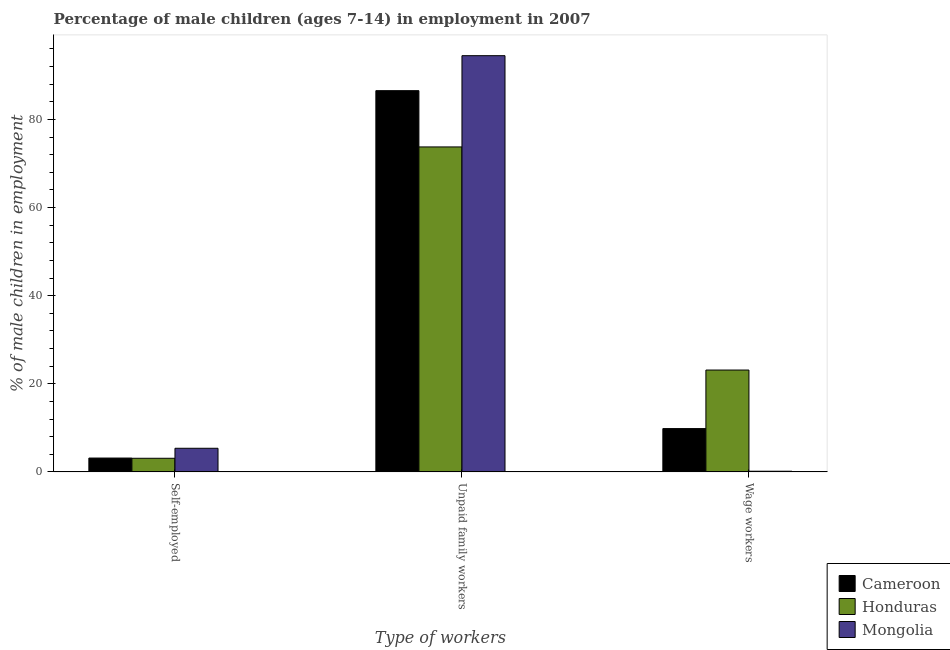How many different coloured bars are there?
Give a very brief answer. 3. How many groups of bars are there?
Keep it short and to the point. 3. Are the number of bars per tick equal to the number of legend labels?
Your response must be concise. Yes. How many bars are there on the 3rd tick from the left?
Keep it short and to the point. 3. How many bars are there on the 3rd tick from the right?
Offer a terse response. 3. What is the label of the 1st group of bars from the left?
Keep it short and to the point. Self-employed. What is the percentage of children employed as unpaid family workers in Mongolia?
Make the answer very short. 94.48. Across all countries, what is the maximum percentage of children employed as unpaid family workers?
Make the answer very short. 94.48. Across all countries, what is the minimum percentage of children employed as unpaid family workers?
Your answer should be very brief. 73.77. In which country was the percentage of self employed children maximum?
Offer a very short reply. Mongolia. In which country was the percentage of self employed children minimum?
Your answer should be compact. Honduras. What is the total percentage of children employed as wage workers in the graph?
Make the answer very short. 33.13. What is the difference between the percentage of self employed children in Honduras and that in Mongolia?
Offer a very short reply. -2.27. What is the difference between the percentage of children employed as unpaid family workers in Honduras and the percentage of self employed children in Mongolia?
Give a very brief answer. 68.4. What is the average percentage of children employed as unpaid family workers per country?
Make the answer very short. 84.93. What is the difference between the percentage of children employed as unpaid family workers and percentage of self employed children in Cameroon?
Provide a short and direct response. 83.39. What is the ratio of the percentage of children employed as unpaid family workers in Cameroon to that in Mongolia?
Give a very brief answer. 0.92. Is the percentage of children employed as wage workers in Mongolia less than that in Honduras?
Offer a terse response. Yes. Is the difference between the percentage of children employed as wage workers in Mongolia and Cameroon greater than the difference between the percentage of children employed as unpaid family workers in Mongolia and Cameroon?
Make the answer very short. No. What is the difference between the highest and the second highest percentage of self employed children?
Your answer should be compact. 2.22. What is the difference between the highest and the lowest percentage of children employed as unpaid family workers?
Provide a succinct answer. 20.71. What does the 1st bar from the left in Wage workers represents?
Provide a succinct answer. Cameroon. What does the 2nd bar from the right in Self-employed represents?
Give a very brief answer. Honduras. How many bars are there?
Your response must be concise. 9. What is the difference between two consecutive major ticks on the Y-axis?
Make the answer very short. 20. Are the values on the major ticks of Y-axis written in scientific E-notation?
Your answer should be very brief. No. Does the graph contain any zero values?
Your answer should be compact. No. Where does the legend appear in the graph?
Your answer should be compact. Bottom right. How many legend labels are there?
Make the answer very short. 3. How are the legend labels stacked?
Provide a short and direct response. Vertical. What is the title of the graph?
Keep it short and to the point. Percentage of male children (ages 7-14) in employment in 2007. What is the label or title of the X-axis?
Provide a succinct answer. Type of workers. What is the label or title of the Y-axis?
Your answer should be compact. % of male children in employment. What is the % of male children in employment in Cameroon in Self-employed?
Ensure brevity in your answer.  3.15. What is the % of male children in employment of Mongolia in Self-employed?
Your answer should be very brief. 5.37. What is the % of male children in employment in Cameroon in Unpaid family workers?
Provide a succinct answer. 86.54. What is the % of male children in employment in Honduras in Unpaid family workers?
Your answer should be compact. 73.77. What is the % of male children in employment of Mongolia in Unpaid family workers?
Provide a succinct answer. 94.48. What is the % of male children in employment in Cameroon in Wage workers?
Provide a succinct answer. 9.84. What is the % of male children in employment of Honduras in Wage workers?
Provide a short and direct response. 23.13. What is the % of male children in employment in Mongolia in Wage workers?
Ensure brevity in your answer.  0.16. Across all Type of workers, what is the maximum % of male children in employment in Cameroon?
Provide a short and direct response. 86.54. Across all Type of workers, what is the maximum % of male children in employment in Honduras?
Provide a succinct answer. 73.77. Across all Type of workers, what is the maximum % of male children in employment in Mongolia?
Offer a terse response. 94.48. Across all Type of workers, what is the minimum % of male children in employment of Cameroon?
Offer a terse response. 3.15. Across all Type of workers, what is the minimum % of male children in employment of Mongolia?
Your answer should be compact. 0.16. What is the total % of male children in employment of Cameroon in the graph?
Your answer should be very brief. 99.53. What is the total % of male children in employment of Honduras in the graph?
Keep it short and to the point. 100. What is the total % of male children in employment of Mongolia in the graph?
Offer a terse response. 100.01. What is the difference between the % of male children in employment of Cameroon in Self-employed and that in Unpaid family workers?
Ensure brevity in your answer.  -83.39. What is the difference between the % of male children in employment of Honduras in Self-employed and that in Unpaid family workers?
Keep it short and to the point. -70.67. What is the difference between the % of male children in employment in Mongolia in Self-employed and that in Unpaid family workers?
Offer a terse response. -89.11. What is the difference between the % of male children in employment in Cameroon in Self-employed and that in Wage workers?
Give a very brief answer. -6.69. What is the difference between the % of male children in employment in Honduras in Self-employed and that in Wage workers?
Provide a succinct answer. -20.03. What is the difference between the % of male children in employment of Mongolia in Self-employed and that in Wage workers?
Keep it short and to the point. 5.21. What is the difference between the % of male children in employment in Cameroon in Unpaid family workers and that in Wage workers?
Provide a succinct answer. 76.7. What is the difference between the % of male children in employment of Honduras in Unpaid family workers and that in Wage workers?
Provide a short and direct response. 50.64. What is the difference between the % of male children in employment of Mongolia in Unpaid family workers and that in Wage workers?
Offer a very short reply. 94.32. What is the difference between the % of male children in employment in Cameroon in Self-employed and the % of male children in employment in Honduras in Unpaid family workers?
Provide a succinct answer. -70.62. What is the difference between the % of male children in employment in Cameroon in Self-employed and the % of male children in employment in Mongolia in Unpaid family workers?
Make the answer very short. -91.33. What is the difference between the % of male children in employment of Honduras in Self-employed and the % of male children in employment of Mongolia in Unpaid family workers?
Ensure brevity in your answer.  -91.38. What is the difference between the % of male children in employment in Cameroon in Self-employed and the % of male children in employment in Honduras in Wage workers?
Provide a short and direct response. -19.98. What is the difference between the % of male children in employment in Cameroon in Self-employed and the % of male children in employment in Mongolia in Wage workers?
Make the answer very short. 2.99. What is the difference between the % of male children in employment of Honduras in Self-employed and the % of male children in employment of Mongolia in Wage workers?
Your response must be concise. 2.94. What is the difference between the % of male children in employment of Cameroon in Unpaid family workers and the % of male children in employment of Honduras in Wage workers?
Keep it short and to the point. 63.41. What is the difference between the % of male children in employment of Cameroon in Unpaid family workers and the % of male children in employment of Mongolia in Wage workers?
Provide a succinct answer. 86.38. What is the difference between the % of male children in employment of Honduras in Unpaid family workers and the % of male children in employment of Mongolia in Wage workers?
Your answer should be very brief. 73.61. What is the average % of male children in employment in Cameroon per Type of workers?
Offer a very short reply. 33.18. What is the average % of male children in employment of Honduras per Type of workers?
Give a very brief answer. 33.33. What is the average % of male children in employment of Mongolia per Type of workers?
Give a very brief answer. 33.34. What is the difference between the % of male children in employment of Cameroon and % of male children in employment of Honduras in Self-employed?
Provide a succinct answer. 0.05. What is the difference between the % of male children in employment of Cameroon and % of male children in employment of Mongolia in Self-employed?
Keep it short and to the point. -2.22. What is the difference between the % of male children in employment in Honduras and % of male children in employment in Mongolia in Self-employed?
Make the answer very short. -2.27. What is the difference between the % of male children in employment of Cameroon and % of male children in employment of Honduras in Unpaid family workers?
Ensure brevity in your answer.  12.77. What is the difference between the % of male children in employment in Cameroon and % of male children in employment in Mongolia in Unpaid family workers?
Your answer should be very brief. -7.94. What is the difference between the % of male children in employment in Honduras and % of male children in employment in Mongolia in Unpaid family workers?
Provide a short and direct response. -20.71. What is the difference between the % of male children in employment of Cameroon and % of male children in employment of Honduras in Wage workers?
Ensure brevity in your answer.  -13.29. What is the difference between the % of male children in employment in Cameroon and % of male children in employment in Mongolia in Wage workers?
Offer a very short reply. 9.68. What is the difference between the % of male children in employment in Honduras and % of male children in employment in Mongolia in Wage workers?
Your response must be concise. 22.97. What is the ratio of the % of male children in employment in Cameroon in Self-employed to that in Unpaid family workers?
Give a very brief answer. 0.04. What is the ratio of the % of male children in employment in Honduras in Self-employed to that in Unpaid family workers?
Keep it short and to the point. 0.04. What is the ratio of the % of male children in employment of Mongolia in Self-employed to that in Unpaid family workers?
Offer a terse response. 0.06. What is the ratio of the % of male children in employment in Cameroon in Self-employed to that in Wage workers?
Provide a short and direct response. 0.32. What is the ratio of the % of male children in employment of Honduras in Self-employed to that in Wage workers?
Ensure brevity in your answer.  0.13. What is the ratio of the % of male children in employment in Mongolia in Self-employed to that in Wage workers?
Keep it short and to the point. 33.56. What is the ratio of the % of male children in employment in Cameroon in Unpaid family workers to that in Wage workers?
Offer a very short reply. 8.79. What is the ratio of the % of male children in employment of Honduras in Unpaid family workers to that in Wage workers?
Provide a succinct answer. 3.19. What is the ratio of the % of male children in employment in Mongolia in Unpaid family workers to that in Wage workers?
Offer a terse response. 590.5. What is the difference between the highest and the second highest % of male children in employment in Cameroon?
Provide a short and direct response. 76.7. What is the difference between the highest and the second highest % of male children in employment of Honduras?
Make the answer very short. 50.64. What is the difference between the highest and the second highest % of male children in employment in Mongolia?
Make the answer very short. 89.11. What is the difference between the highest and the lowest % of male children in employment of Cameroon?
Offer a very short reply. 83.39. What is the difference between the highest and the lowest % of male children in employment in Honduras?
Ensure brevity in your answer.  70.67. What is the difference between the highest and the lowest % of male children in employment in Mongolia?
Your answer should be very brief. 94.32. 